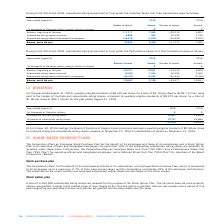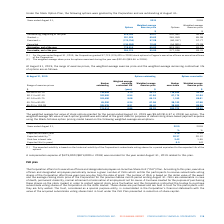According to Cogeco's financial document, What percentage of outstanding subordinate shares are available for issuance under the corporation offer? According to the financial document, 10%. The relevant text states: "ve officers and designated employees. No more than 10% of the outstanding subordinate voting shares are available for issuance under these plans. Furthermo..." Also, What maximum percentage of employee's base annual salary can be used for Employee Stock Purchase Plan? According to the financial document, 7%. The relevant text states: "is accessible to all employees up to a maximum of 7% of their base annual salary and the Corporation contributes 25% of the employee contributions. The s..." Also, What is the total number of shares under Stock option plan A? 3,432,500 subordinate voting shares. The document states: "A total of 3,432,500 subordinate voting shares are reserved for the purpose of the Stock Option Plan. The minimum exercise price at which options..." Also, can you calculate: What is the increase / (decrease) in the Options Outstanding, beginning of the year shares from 2018 to 2019? Based on the calculation: 819,393 - 652,385, the result is 167008. This is based on the information: "Outstanding, beginning of the year 819,393 65.27 652,385 56.61 Outstanding, beginning of the year 819,393 65.27 652,385 56.61..." The key data points involved are: 652,385, 819,393. Also, can you calculate: What is the average options granted from 2018 to 2019? To answer this question, I need to perform calculations using the financial data. The calculation is: (201,525 + 281,350) / 2, which equals 241437.5. This is based on the information: "Granted (1) 201,525 65.62 281,350 85.08 Granted (1) 201,525 65.62 281,350 85.08..." The key data points involved are: 201,525, 281,350. Also, can you calculate: What is the average Outstanding, end of the year options from 2018 to 2019? To answer this question, I need to perform calculations using the financial data. The calculation is: (715,614 + 819,393) / 2, which equals 767503.5. This is based on the information: "Outstanding, end of the year 715,614 65.93 819,393 65.27 Outstanding, end of the year 715,614 65.93 819,393 65.27..." The key data points involved are: 715,614, 819,393. 